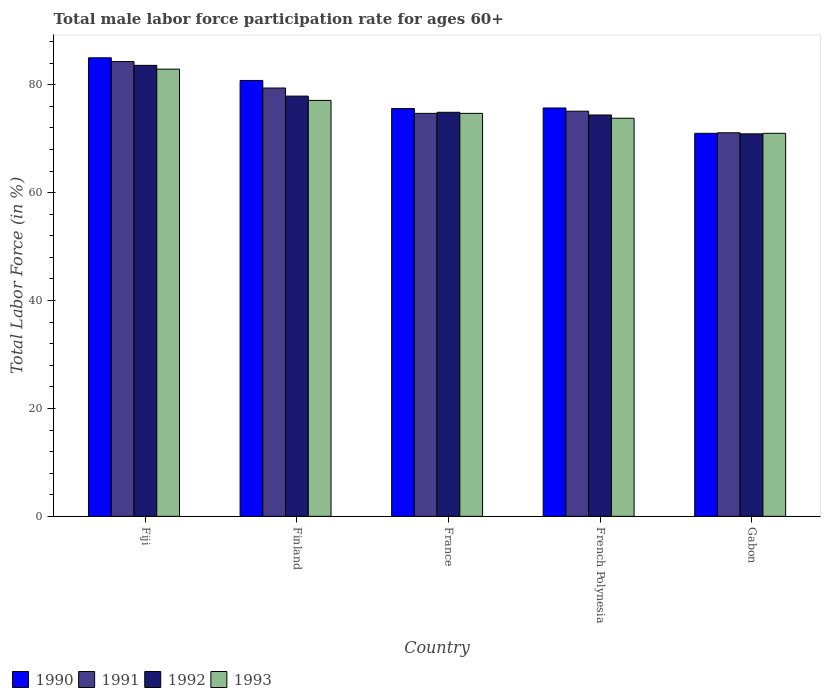How many different coloured bars are there?
Keep it short and to the point. 4. How many groups of bars are there?
Give a very brief answer. 5. Are the number of bars per tick equal to the number of legend labels?
Offer a terse response. Yes. Are the number of bars on each tick of the X-axis equal?
Provide a short and direct response. Yes. What is the label of the 3rd group of bars from the left?
Your answer should be very brief. France. In how many cases, is the number of bars for a given country not equal to the number of legend labels?
Offer a terse response. 0. What is the male labor force participation rate in 1992 in France?
Your answer should be very brief. 74.9. Across all countries, what is the maximum male labor force participation rate in 1991?
Make the answer very short. 84.3. Across all countries, what is the minimum male labor force participation rate in 1993?
Ensure brevity in your answer.  71. In which country was the male labor force participation rate in 1992 maximum?
Provide a short and direct response. Fiji. In which country was the male labor force participation rate in 1991 minimum?
Ensure brevity in your answer.  Gabon. What is the total male labor force participation rate in 1993 in the graph?
Your answer should be compact. 379.5. What is the difference between the male labor force participation rate in 1993 in Gabon and the male labor force participation rate in 1991 in France?
Your answer should be very brief. -3.7. What is the average male labor force participation rate in 1991 per country?
Keep it short and to the point. 76.92. What is the difference between the male labor force participation rate of/in 1993 and male labor force participation rate of/in 1991 in Gabon?
Provide a succinct answer. -0.1. In how many countries, is the male labor force participation rate in 1993 greater than 44 %?
Offer a very short reply. 5. What is the ratio of the male labor force participation rate in 1992 in France to that in Gabon?
Provide a succinct answer. 1.06. What is the difference between the highest and the second highest male labor force participation rate in 1990?
Provide a short and direct response. 5.1. What is the difference between the highest and the lowest male labor force participation rate in 1992?
Provide a succinct answer. 12.7. In how many countries, is the male labor force participation rate in 1992 greater than the average male labor force participation rate in 1992 taken over all countries?
Your answer should be very brief. 2. What does the 1st bar from the left in Gabon represents?
Your answer should be compact. 1990. What does the 2nd bar from the right in Gabon represents?
Keep it short and to the point. 1992. Is it the case that in every country, the sum of the male labor force participation rate in 1991 and male labor force participation rate in 1990 is greater than the male labor force participation rate in 1993?
Your answer should be very brief. Yes. How many bars are there?
Offer a very short reply. 20. Are all the bars in the graph horizontal?
Offer a very short reply. No. How many countries are there in the graph?
Make the answer very short. 5. Does the graph contain grids?
Provide a succinct answer. No. What is the title of the graph?
Your answer should be very brief. Total male labor force participation rate for ages 60+. What is the Total Labor Force (in %) of 1991 in Fiji?
Give a very brief answer. 84.3. What is the Total Labor Force (in %) in 1992 in Fiji?
Offer a very short reply. 83.6. What is the Total Labor Force (in %) in 1993 in Fiji?
Offer a very short reply. 82.9. What is the Total Labor Force (in %) in 1990 in Finland?
Make the answer very short. 80.8. What is the Total Labor Force (in %) of 1991 in Finland?
Offer a very short reply. 79.4. What is the Total Labor Force (in %) in 1992 in Finland?
Keep it short and to the point. 77.9. What is the Total Labor Force (in %) in 1993 in Finland?
Make the answer very short. 77.1. What is the Total Labor Force (in %) in 1990 in France?
Offer a very short reply. 75.6. What is the Total Labor Force (in %) in 1991 in France?
Your answer should be very brief. 74.7. What is the Total Labor Force (in %) of 1992 in France?
Ensure brevity in your answer.  74.9. What is the Total Labor Force (in %) in 1993 in France?
Keep it short and to the point. 74.7. What is the Total Labor Force (in %) of 1990 in French Polynesia?
Offer a very short reply. 75.7. What is the Total Labor Force (in %) in 1991 in French Polynesia?
Ensure brevity in your answer.  75.1. What is the Total Labor Force (in %) in 1992 in French Polynesia?
Your answer should be very brief. 74.4. What is the Total Labor Force (in %) in 1993 in French Polynesia?
Offer a terse response. 73.8. What is the Total Labor Force (in %) of 1990 in Gabon?
Provide a succinct answer. 71. What is the Total Labor Force (in %) of 1991 in Gabon?
Your answer should be compact. 71.1. What is the Total Labor Force (in %) of 1992 in Gabon?
Provide a short and direct response. 70.9. What is the Total Labor Force (in %) of 1993 in Gabon?
Ensure brevity in your answer.  71. Across all countries, what is the maximum Total Labor Force (in %) in 1990?
Your answer should be compact. 85. Across all countries, what is the maximum Total Labor Force (in %) of 1991?
Keep it short and to the point. 84.3. Across all countries, what is the maximum Total Labor Force (in %) of 1992?
Your answer should be compact. 83.6. Across all countries, what is the maximum Total Labor Force (in %) of 1993?
Your answer should be compact. 82.9. Across all countries, what is the minimum Total Labor Force (in %) of 1990?
Provide a short and direct response. 71. Across all countries, what is the minimum Total Labor Force (in %) in 1991?
Your answer should be very brief. 71.1. Across all countries, what is the minimum Total Labor Force (in %) in 1992?
Provide a succinct answer. 70.9. Across all countries, what is the minimum Total Labor Force (in %) of 1993?
Ensure brevity in your answer.  71. What is the total Total Labor Force (in %) of 1990 in the graph?
Make the answer very short. 388.1. What is the total Total Labor Force (in %) in 1991 in the graph?
Provide a succinct answer. 384.6. What is the total Total Labor Force (in %) in 1992 in the graph?
Provide a short and direct response. 381.7. What is the total Total Labor Force (in %) of 1993 in the graph?
Offer a very short reply. 379.5. What is the difference between the Total Labor Force (in %) in 1993 in Fiji and that in Finland?
Make the answer very short. 5.8. What is the difference between the Total Labor Force (in %) in 1990 in Fiji and that in France?
Your response must be concise. 9.4. What is the difference between the Total Labor Force (in %) in 1992 in Fiji and that in France?
Ensure brevity in your answer.  8.7. What is the difference between the Total Labor Force (in %) in 1990 in Fiji and that in French Polynesia?
Provide a short and direct response. 9.3. What is the difference between the Total Labor Force (in %) of 1991 in Fiji and that in French Polynesia?
Provide a succinct answer. 9.2. What is the difference between the Total Labor Force (in %) in 1993 in Fiji and that in French Polynesia?
Your answer should be very brief. 9.1. What is the difference between the Total Labor Force (in %) in 1990 in Fiji and that in Gabon?
Ensure brevity in your answer.  14. What is the difference between the Total Labor Force (in %) in 1992 in Fiji and that in Gabon?
Provide a short and direct response. 12.7. What is the difference between the Total Labor Force (in %) of 1990 in Finland and that in France?
Your answer should be compact. 5.2. What is the difference between the Total Labor Force (in %) of 1992 in Finland and that in France?
Keep it short and to the point. 3. What is the difference between the Total Labor Force (in %) in 1993 in Finland and that in France?
Provide a succinct answer. 2.4. What is the difference between the Total Labor Force (in %) of 1990 in Finland and that in Gabon?
Your answer should be compact. 9.8. What is the difference between the Total Labor Force (in %) in 1993 in Finland and that in Gabon?
Provide a succinct answer. 6.1. What is the difference between the Total Labor Force (in %) in 1990 in France and that in French Polynesia?
Ensure brevity in your answer.  -0.1. What is the difference between the Total Labor Force (in %) in 1991 in France and that in French Polynesia?
Provide a short and direct response. -0.4. What is the difference between the Total Labor Force (in %) of 1991 in France and that in Gabon?
Give a very brief answer. 3.6. What is the difference between the Total Labor Force (in %) of 1990 in French Polynesia and that in Gabon?
Offer a very short reply. 4.7. What is the difference between the Total Labor Force (in %) in 1991 in French Polynesia and that in Gabon?
Ensure brevity in your answer.  4. What is the difference between the Total Labor Force (in %) in 1993 in French Polynesia and that in Gabon?
Your answer should be very brief. 2.8. What is the difference between the Total Labor Force (in %) in 1990 in Fiji and the Total Labor Force (in %) in 1992 in Finland?
Offer a very short reply. 7.1. What is the difference between the Total Labor Force (in %) of 1990 in Fiji and the Total Labor Force (in %) of 1993 in Finland?
Offer a terse response. 7.9. What is the difference between the Total Labor Force (in %) of 1991 in Fiji and the Total Labor Force (in %) of 1993 in Finland?
Give a very brief answer. 7.2. What is the difference between the Total Labor Force (in %) in 1992 in Fiji and the Total Labor Force (in %) in 1993 in Finland?
Provide a succinct answer. 6.5. What is the difference between the Total Labor Force (in %) in 1990 in Fiji and the Total Labor Force (in %) in 1991 in France?
Give a very brief answer. 10.3. What is the difference between the Total Labor Force (in %) of 1990 in Fiji and the Total Labor Force (in %) of 1992 in France?
Your answer should be compact. 10.1. What is the difference between the Total Labor Force (in %) in 1991 in Fiji and the Total Labor Force (in %) in 1992 in France?
Give a very brief answer. 9.4. What is the difference between the Total Labor Force (in %) in 1992 in Fiji and the Total Labor Force (in %) in 1993 in France?
Give a very brief answer. 8.9. What is the difference between the Total Labor Force (in %) of 1990 in Fiji and the Total Labor Force (in %) of 1991 in French Polynesia?
Make the answer very short. 9.9. What is the difference between the Total Labor Force (in %) of 1990 in Fiji and the Total Labor Force (in %) of 1993 in French Polynesia?
Your response must be concise. 11.2. What is the difference between the Total Labor Force (in %) of 1991 in Fiji and the Total Labor Force (in %) of 1993 in French Polynesia?
Offer a terse response. 10.5. What is the difference between the Total Labor Force (in %) of 1992 in Fiji and the Total Labor Force (in %) of 1993 in French Polynesia?
Keep it short and to the point. 9.8. What is the difference between the Total Labor Force (in %) in 1990 in Fiji and the Total Labor Force (in %) in 1991 in Gabon?
Provide a short and direct response. 13.9. What is the difference between the Total Labor Force (in %) of 1990 in Fiji and the Total Labor Force (in %) of 1992 in Gabon?
Your answer should be compact. 14.1. What is the difference between the Total Labor Force (in %) of 1990 in Fiji and the Total Labor Force (in %) of 1993 in Gabon?
Make the answer very short. 14. What is the difference between the Total Labor Force (in %) in 1991 in Fiji and the Total Labor Force (in %) in 1992 in Gabon?
Make the answer very short. 13.4. What is the difference between the Total Labor Force (in %) in 1991 in Fiji and the Total Labor Force (in %) in 1993 in Gabon?
Keep it short and to the point. 13.3. What is the difference between the Total Labor Force (in %) in 1992 in Fiji and the Total Labor Force (in %) in 1993 in Gabon?
Provide a short and direct response. 12.6. What is the difference between the Total Labor Force (in %) in 1990 in Finland and the Total Labor Force (in %) in 1992 in France?
Your response must be concise. 5.9. What is the difference between the Total Labor Force (in %) in 1992 in Finland and the Total Labor Force (in %) in 1993 in France?
Your answer should be very brief. 3.2. What is the difference between the Total Labor Force (in %) of 1990 in Finland and the Total Labor Force (in %) of 1991 in French Polynesia?
Provide a short and direct response. 5.7. What is the difference between the Total Labor Force (in %) in 1990 in Finland and the Total Labor Force (in %) in 1992 in French Polynesia?
Give a very brief answer. 6.4. What is the difference between the Total Labor Force (in %) of 1991 in Finland and the Total Labor Force (in %) of 1993 in French Polynesia?
Make the answer very short. 5.6. What is the difference between the Total Labor Force (in %) in 1990 in Finland and the Total Labor Force (in %) in 1991 in Gabon?
Your answer should be compact. 9.7. What is the difference between the Total Labor Force (in %) of 1990 in Finland and the Total Labor Force (in %) of 1992 in Gabon?
Provide a succinct answer. 9.9. What is the difference between the Total Labor Force (in %) in 1991 in Finland and the Total Labor Force (in %) in 1992 in Gabon?
Provide a succinct answer. 8.5. What is the difference between the Total Labor Force (in %) of 1991 in Finland and the Total Labor Force (in %) of 1993 in Gabon?
Your response must be concise. 8.4. What is the difference between the Total Labor Force (in %) of 1992 in Finland and the Total Labor Force (in %) of 1993 in Gabon?
Ensure brevity in your answer.  6.9. What is the difference between the Total Labor Force (in %) of 1990 in France and the Total Labor Force (in %) of 1992 in French Polynesia?
Offer a very short reply. 1.2. What is the difference between the Total Labor Force (in %) in 1990 in France and the Total Labor Force (in %) in 1993 in French Polynesia?
Give a very brief answer. 1.8. What is the difference between the Total Labor Force (in %) of 1990 in France and the Total Labor Force (in %) of 1991 in Gabon?
Keep it short and to the point. 4.5. What is the difference between the Total Labor Force (in %) in 1990 in France and the Total Labor Force (in %) in 1992 in Gabon?
Your answer should be compact. 4.7. What is the difference between the Total Labor Force (in %) in 1990 in France and the Total Labor Force (in %) in 1993 in Gabon?
Offer a very short reply. 4.6. What is the difference between the Total Labor Force (in %) in 1991 in France and the Total Labor Force (in %) in 1993 in Gabon?
Ensure brevity in your answer.  3.7. What is the difference between the Total Labor Force (in %) of 1990 in French Polynesia and the Total Labor Force (in %) of 1991 in Gabon?
Your answer should be very brief. 4.6. What is the difference between the Total Labor Force (in %) of 1990 in French Polynesia and the Total Labor Force (in %) of 1992 in Gabon?
Keep it short and to the point. 4.8. What is the difference between the Total Labor Force (in %) of 1991 in French Polynesia and the Total Labor Force (in %) of 1992 in Gabon?
Offer a terse response. 4.2. What is the average Total Labor Force (in %) in 1990 per country?
Offer a terse response. 77.62. What is the average Total Labor Force (in %) of 1991 per country?
Provide a short and direct response. 76.92. What is the average Total Labor Force (in %) in 1992 per country?
Your answer should be very brief. 76.34. What is the average Total Labor Force (in %) in 1993 per country?
Ensure brevity in your answer.  75.9. What is the difference between the Total Labor Force (in %) of 1990 and Total Labor Force (in %) of 1991 in Fiji?
Ensure brevity in your answer.  0.7. What is the difference between the Total Labor Force (in %) of 1990 and Total Labor Force (in %) of 1992 in Fiji?
Your response must be concise. 1.4. What is the difference between the Total Labor Force (in %) of 1990 and Total Labor Force (in %) of 1993 in Fiji?
Keep it short and to the point. 2.1. What is the difference between the Total Labor Force (in %) in 1991 and Total Labor Force (in %) in 1992 in Fiji?
Make the answer very short. 0.7. What is the difference between the Total Labor Force (in %) in 1991 and Total Labor Force (in %) in 1993 in Fiji?
Provide a short and direct response. 1.4. What is the difference between the Total Labor Force (in %) in 1992 and Total Labor Force (in %) in 1993 in Fiji?
Your answer should be very brief. 0.7. What is the difference between the Total Labor Force (in %) in 1990 and Total Labor Force (in %) in 1993 in Finland?
Provide a succinct answer. 3.7. What is the difference between the Total Labor Force (in %) of 1991 and Total Labor Force (in %) of 1993 in Finland?
Your answer should be very brief. 2.3. What is the difference between the Total Labor Force (in %) of 1992 and Total Labor Force (in %) of 1993 in Finland?
Offer a very short reply. 0.8. What is the difference between the Total Labor Force (in %) in 1990 and Total Labor Force (in %) in 1991 in France?
Provide a short and direct response. 0.9. What is the difference between the Total Labor Force (in %) of 1990 and Total Labor Force (in %) of 1992 in France?
Make the answer very short. 0.7. What is the difference between the Total Labor Force (in %) in 1991 and Total Labor Force (in %) in 1992 in France?
Keep it short and to the point. -0.2. What is the difference between the Total Labor Force (in %) in 1991 and Total Labor Force (in %) in 1993 in France?
Give a very brief answer. 0. What is the difference between the Total Labor Force (in %) in 1992 and Total Labor Force (in %) in 1993 in France?
Your answer should be very brief. 0.2. What is the difference between the Total Labor Force (in %) of 1990 and Total Labor Force (in %) of 1993 in French Polynesia?
Keep it short and to the point. 1.9. What is the difference between the Total Labor Force (in %) in 1991 and Total Labor Force (in %) in 1993 in French Polynesia?
Ensure brevity in your answer.  1.3. What is the difference between the Total Labor Force (in %) in 1992 and Total Labor Force (in %) in 1993 in French Polynesia?
Give a very brief answer. 0.6. What is the difference between the Total Labor Force (in %) in 1990 and Total Labor Force (in %) in 1991 in Gabon?
Your answer should be very brief. -0.1. What is the difference between the Total Labor Force (in %) of 1992 and Total Labor Force (in %) of 1993 in Gabon?
Your answer should be very brief. -0.1. What is the ratio of the Total Labor Force (in %) in 1990 in Fiji to that in Finland?
Your answer should be very brief. 1.05. What is the ratio of the Total Labor Force (in %) in 1991 in Fiji to that in Finland?
Provide a succinct answer. 1.06. What is the ratio of the Total Labor Force (in %) of 1992 in Fiji to that in Finland?
Provide a short and direct response. 1.07. What is the ratio of the Total Labor Force (in %) of 1993 in Fiji to that in Finland?
Your answer should be compact. 1.08. What is the ratio of the Total Labor Force (in %) of 1990 in Fiji to that in France?
Offer a very short reply. 1.12. What is the ratio of the Total Labor Force (in %) in 1991 in Fiji to that in France?
Your answer should be very brief. 1.13. What is the ratio of the Total Labor Force (in %) in 1992 in Fiji to that in France?
Your answer should be compact. 1.12. What is the ratio of the Total Labor Force (in %) in 1993 in Fiji to that in France?
Your answer should be compact. 1.11. What is the ratio of the Total Labor Force (in %) in 1990 in Fiji to that in French Polynesia?
Your answer should be very brief. 1.12. What is the ratio of the Total Labor Force (in %) in 1991 in Fiji to that in French Polynesia?
Your answer should be compact. 1.12. What is the ratio of the Total Labor Force (in %) of 1992 in Fiji to that in French Polynesia?
Ensure brevity in your answer.  1.12. What is the ratio of the Total Labor Force (in %) in 1993 in Fiji to that in French Polynesia?
Keep it short and to the point. 1.12. What is the ratio of the Total Labor Force (in %) of 1990 in Fiji to that in Gabon?
Offer a terse response. 1.2. What is the ratio of the Total Labor Force (in %) in 1991 in Fiji to that in Gabon?
Provide a short and direct response. 1.19. What is the ratio of the Total Labor Force (in %) of 1992 in Fiji to that in Gabon?
Your response must be concise. 1.18. What is the ratio of the Total Labor Force (in %) in 1993 in Fiji to that in Gabon?
Ensure brevity in your answer.  1.17. What is the ratio of the Total Labor Force (in %) in 1990 in Finland to that in France?
Keep it short and to the point. 1.07. What is the ratio of the Total Labor Force (in %) of 1991 in Finland to that in France?
Offer a terse response. 1.06. What is the ratio of the Total Labor Force (in %) in 1992 in Finland to that in France?
Offer a terse response. 1.04. What is the ratio of the Total Labor Force (in %) of 1993 in Finland to that in France?
Offer a very short reply. 1.03. What is the ratio of the Total Labor Force (in %) in 1990 in Finland to that in French Polynesia?
Your answer should be very brief. 1.07. What is the ratio of the Total Labor Force (in %) of 1991 in Finland to that in French Polynesia?
Provide a short and direct response. 1.06. What is the ratio of the Total Labor Force (in %) of 1992 in Finland to that in French Polynesia?
Your answer should be very brief. 1.05. What is the ratio of the Total Labor Force (in %) in 1993 in Finland to that in French Polynesia?
Keep it short and to the point. 1.04. What is the ratio of the Total Labor Force (in %) of 1990 in Finland to that in Gabon?
Your answer should be very brief. 1.14. What is the ratio of the Total Labor Force (in %) in 1991 in Finland to that in Gabon?
Give a very brief answer. 1.12. What is the ratio of the Total Labor Force (in %) of 1992 in Finland to that in Gabon?
Provide a succinct answer. 1.1. What is the ratio of the Total Labor Force (in %) in 1993 in Finland to that in Gabon?
Provide a short and direct response. 1.09. What is the ratio of the Total Labor Force (in %) in 1990 in France to that in French Polynesia?
Your response must be concise. 1. What is the ratio of the Total Labor Force (in %) of 1991 in France to that in French Polynesia?
Give a very brief answer. 0.99. What is the ratio of the Total Labor Force (in %) of 1993 in France to that in French Polynesia?
Keep it short and to the point. 1.01. What is the ratio of the Total Labor Force (in %) of 1990 in France to that in Gabon?
Provide a short and direct response. 1.06. What is the ratio of the Total Labor Force (in %) of 1991 in France to that in Gabon?
Your answer should be very brief. 1.05. What is the ratio of the Total Labor Force (in %) in 1992 in France to that in Gabon?
Keep it short and to the point. 1.06. What is the ratio of the Total Labor Force (in %) of 1993 in France to that in Gabon?
Keep it short and to the point. 1.05. What is the ratio of the Total Labor Force (in %) in 1990 in French Polynesia to that in Gabon?
Give a very brief answer. 1.07. What is the ratio of the Total Labor Force (in %) in 1991 in French Polynesia to that in Gabon?
Your answer should be compact. 1.06. What is the ratio of the Total Labor Force (in %) of 1992 in French Polynesia to that in Gabon?
Your answer should be compact. 1.05. What is the ratio of the Total Labor Force (in %) of 1993 in French Polynesia to that in Gabon?
Your answer should be very brief. 1.04. What is the difference between the highest and the lowest Total Labor Force (in %) of 1991?
Keep it short and to the point. 13.2. What is the difference between the highest and the lowest Total Labor Force (in %) of 1992?
Offer a terse response. 12.7. 